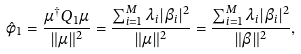<formula> <loc_0><loc_0><loc_500><loc_500>\hat { \phi } _ { 1 } = \frac { \mu ^ { \dag } Q _ { 1 } \mu } { \| \mu \| ^ { 2 } } = \frac { \sum _ { i = 1 } ^ { M } \lambda _ { i } | \beta _ { i } | ^ { 2 } } { \| \mu \| ^ { 2 } } = \frac { \sum _ { i = 1 } ^ { M } \lambda _ { i } | \beta _ { i } | ^ { 2 } } { \| \beta \| ^ { 2 } } ,</formula> 